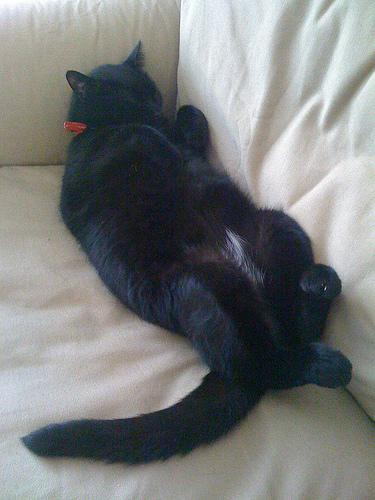Question: what type of animal is shown?
Choices:
A. Dog.
B. Horse.
C. Cat.
D. Rabbit.
Answer with the letter. Answer: C Question: what is the cat laying on?
Choices:
A. Bed.
B. Pillow.
C. Chair.
D. Couch.
Answer with the letter. Answer: D Question: what color is the couch?
Choices:
A. Brown.
B. Black.
C. Tan.
D. White.
Answer with the letter. Answer: C Question: where was the photo taken?
Choices:
A. On the chair.
B. On a couch.
C. On the floor.
D. Near the table.
Answer with the letter. Answer: B 